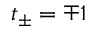Convert formula to latex. <formula><loc_0><loc_0><loc_500><loc_500>t _ { \pm } = \mp 1</formula> 